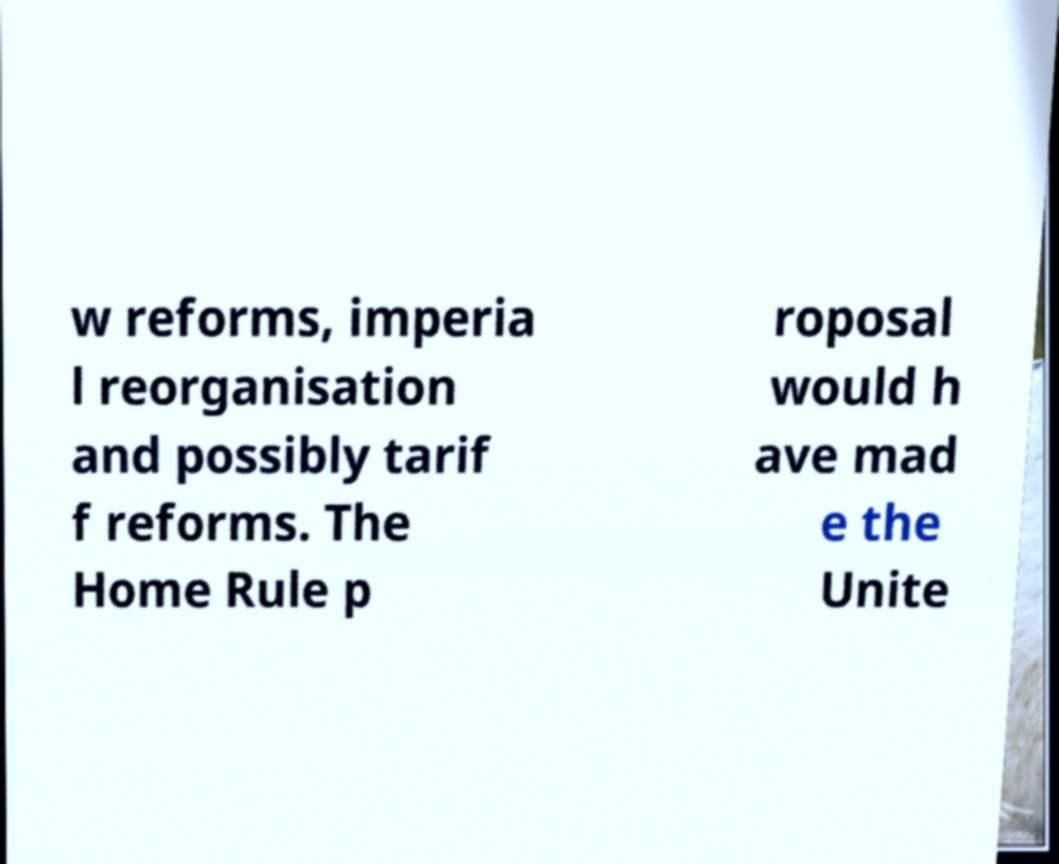Please identify and transcribe the text found in this image. w reforms, imperia l reorganisation and possibly tarif f reforms. The Home Rule p roposal would h ave mad e the Unite 